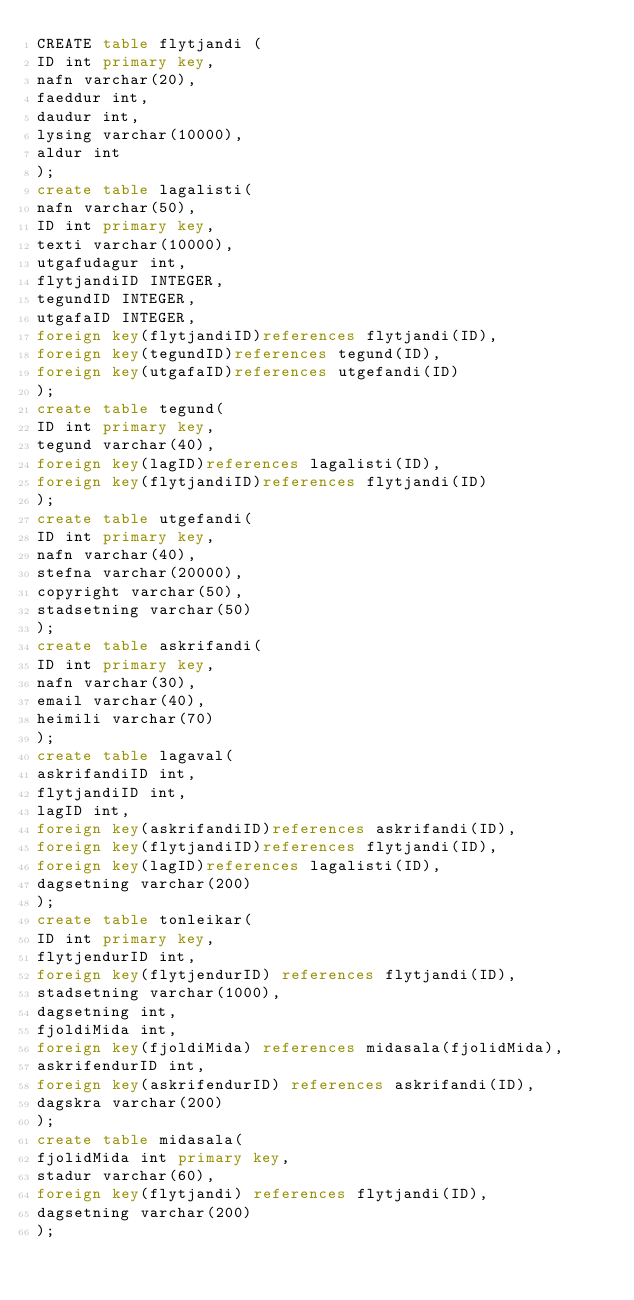Convert code to text. <code><loc_0><loc_0><loc_500><loc_500><_SQL_>CREATE table flytjandi (
ID int primary key,
nafn varchar(20),
faeddur int,
daudur int,
lysing varchar(10000),
aldur int
);
create table lagalisti(
nafn varchar(50),
ID int primary key,
texti varchar(10000),
utgafudagur int,
flytjandiID INTEGER,
tegundID INTEGER,
utgafaID INTEGER,
foreign key(flytjandiID)references flytjandi(ID),
foreign key(tegundID)references tegund(ID),
foreign key(utgafaID)references utgefandi(ID)
);
create table tegund(
ID int primary key,
tegund varchar(40),
foreign key(lagID)references lagalisti(ID),
foreign key(flytjandiID)references flytjandi(ID)
);
create table utgefandi(
ID int primary key,
nafn varchar(40),
stefna varchar(20000),
copyright varchar(50),
stadsetning varchar(50)
);
create table askrifandi(
ID int primary key,
nafn varchar(30),
email varchar(40),
heimili varchar(70)
);
create table lagaval(
askrifandiID int,
flytjandiID int,
lagID int,
foreign key(askrifandiID)references askrifandi(ID),
foreign key(flytjandiID)references flytjandi(ID),
foreign key(lagID)references lagalisti(ID),
dagsetning varchar(200)
);
create table tonleikar(
ID int primary key,
flytjendurID int,
foreign key(flytjendurID) references flytjandi(ID),
stadsetning varchar(1000),
dagsetning int,
fjoldiMida int,
foreign key(fjoldiMida) references midasala(fjolidMida),
askrifendurID int,
foreign key(askrifendurID) references askrifandi(ID),
dagskra varchar(200)
);
create table midasala(
fjolidMida int primary key,
stadur varchar(60),
foreign key(flytjandi) references flytjandi(ID),
dagsetning varchar(200)
);</code> 